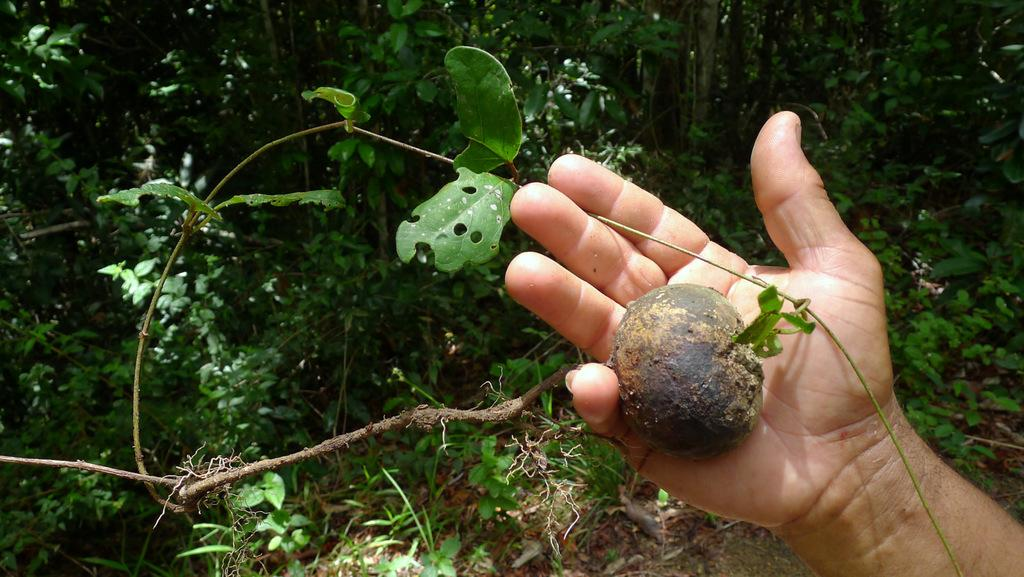What is being held by the hand in the image? There is a hand holding a vegetable in the image. What else can be seen in the image besides the hand and vegetable? There is a plant in the image. What can be seen in the background of the image? There are trees and plants in the background of the image. Where is the grandmother sitting in the image? There is no grandmother present in the image. What type of chain is wrapped around the vegetable in the image? There is no chain present in the image; the vegetable is simply being held by a hand. 